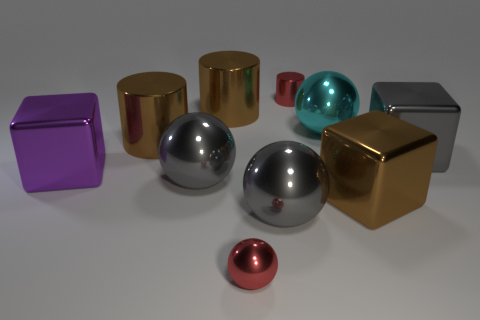Subtract all red cylinders. Subtract all gray balls. How many cylinders are left? 2 Subtract all balls. How many objects are left? 6 Add 1 small shiny cylinders. How many small shiny cylinders exist? 2 Subtract 1 brown blocks. How many objects are left? 9 Subtract all big gray metallic things. Subtract all large gray cubes. How many objects are left? 6 Add 4 small red metal objects. How many small red metal objects are left? 6 